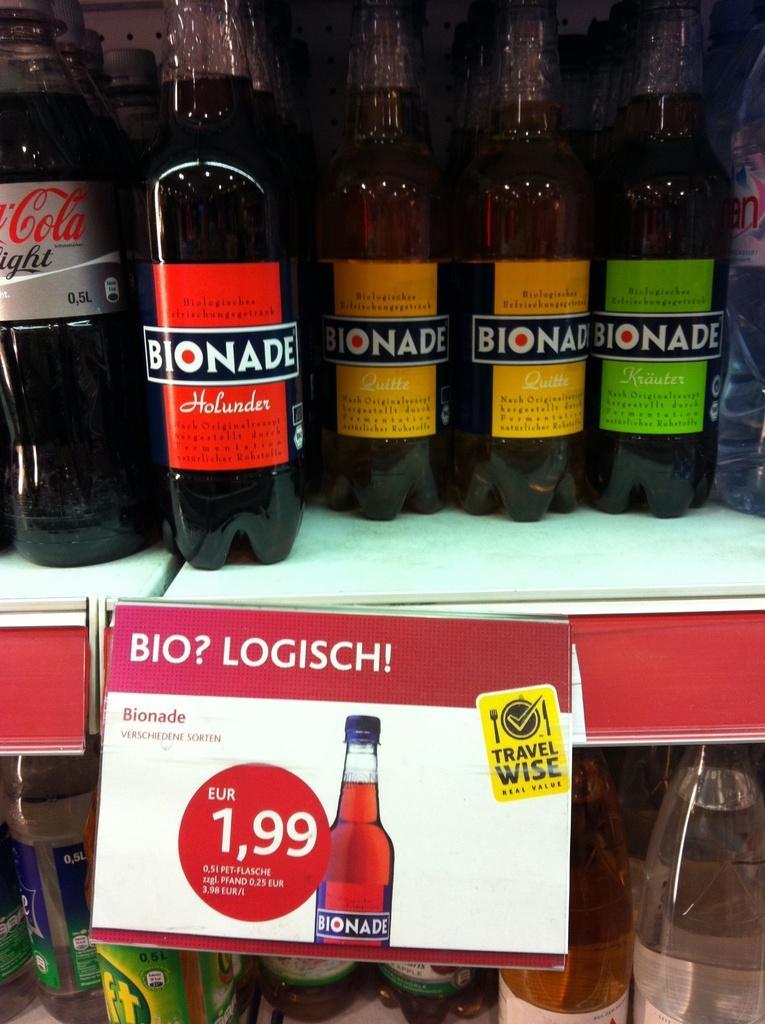Can you describe this image briefly? This picture shows some drink bottles placed in the shelf and a name plate and a price regarding that bottles here. 